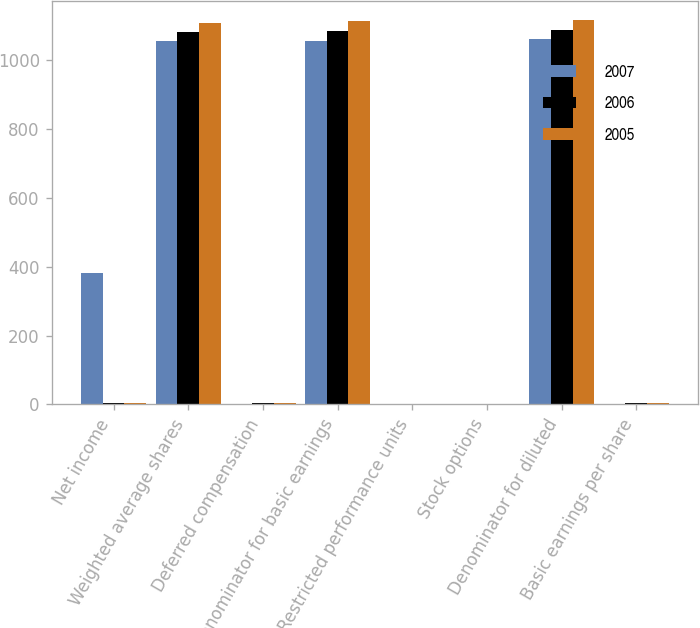Convert chart to OTSL. <chart><loc_0><loc_0><loc_500><loc_500><stacked_bar_chart><ecel><fcel>Net income<fcel>Weighted average shares<fcel>Deferred compensation<fcel>Denominator for basic earnings<fcel>Restricted performance units<fcel>Stock options<fcel>Denominator for diluted<fcel>Basic earnings per share<nl><fcel>2007<fcel>382<fcel>1055<fcel>2<fcel>1057<fcel>2<fcel>2<fcel>1063<fcel>0.36<nl><fcel>2006<fcel>3.675<fcel>1082<fcel>3<fcel>1085<fcel>1<fcel>2<fcel>1089<fcel>3.87<nl><fcel>2005<fcel>3.675<fcel>1110<fcel>3<fcel>1113<fcel>1<fcel>2<fcel>1116<fcel>3.48<nl></chart> 